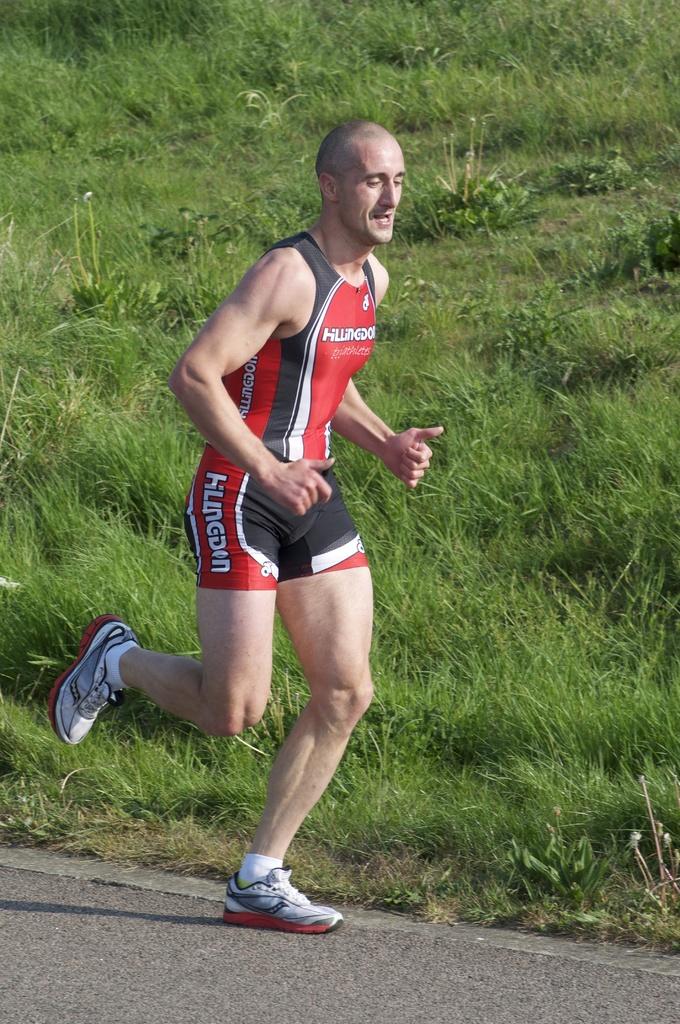What is the name on his shirt?
Provide a succinct answer. Unanswerable. 